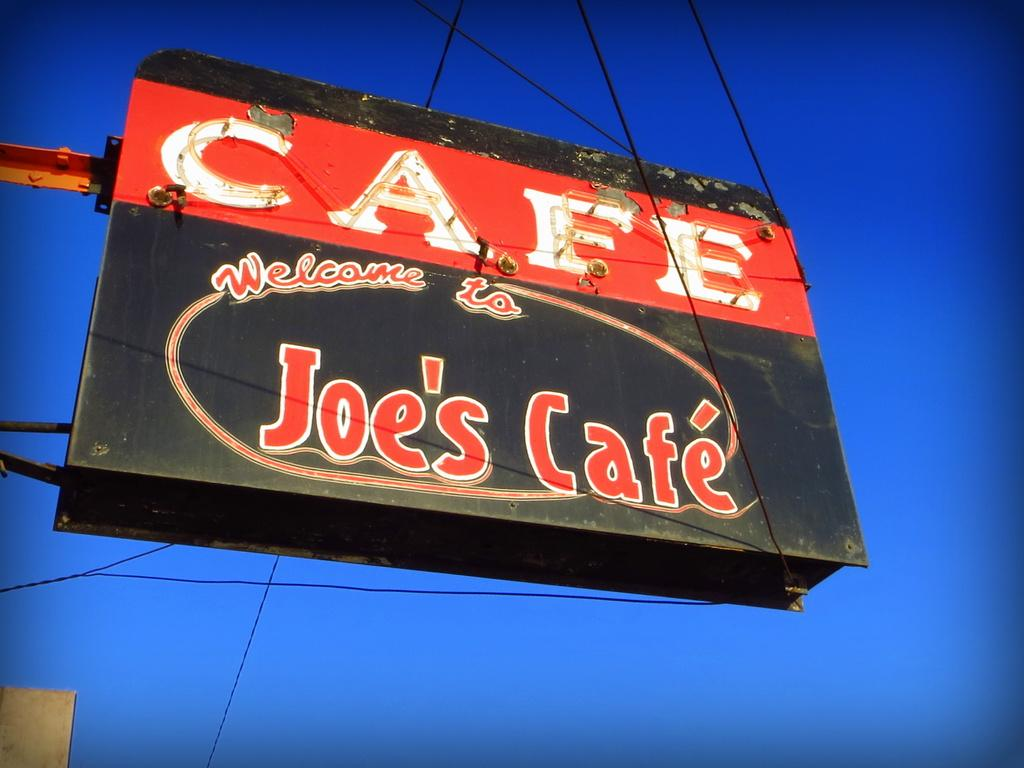<image>
Present a compact description of the photo's key features. The Cafe is called Joe's Cafe and is welcoming you 